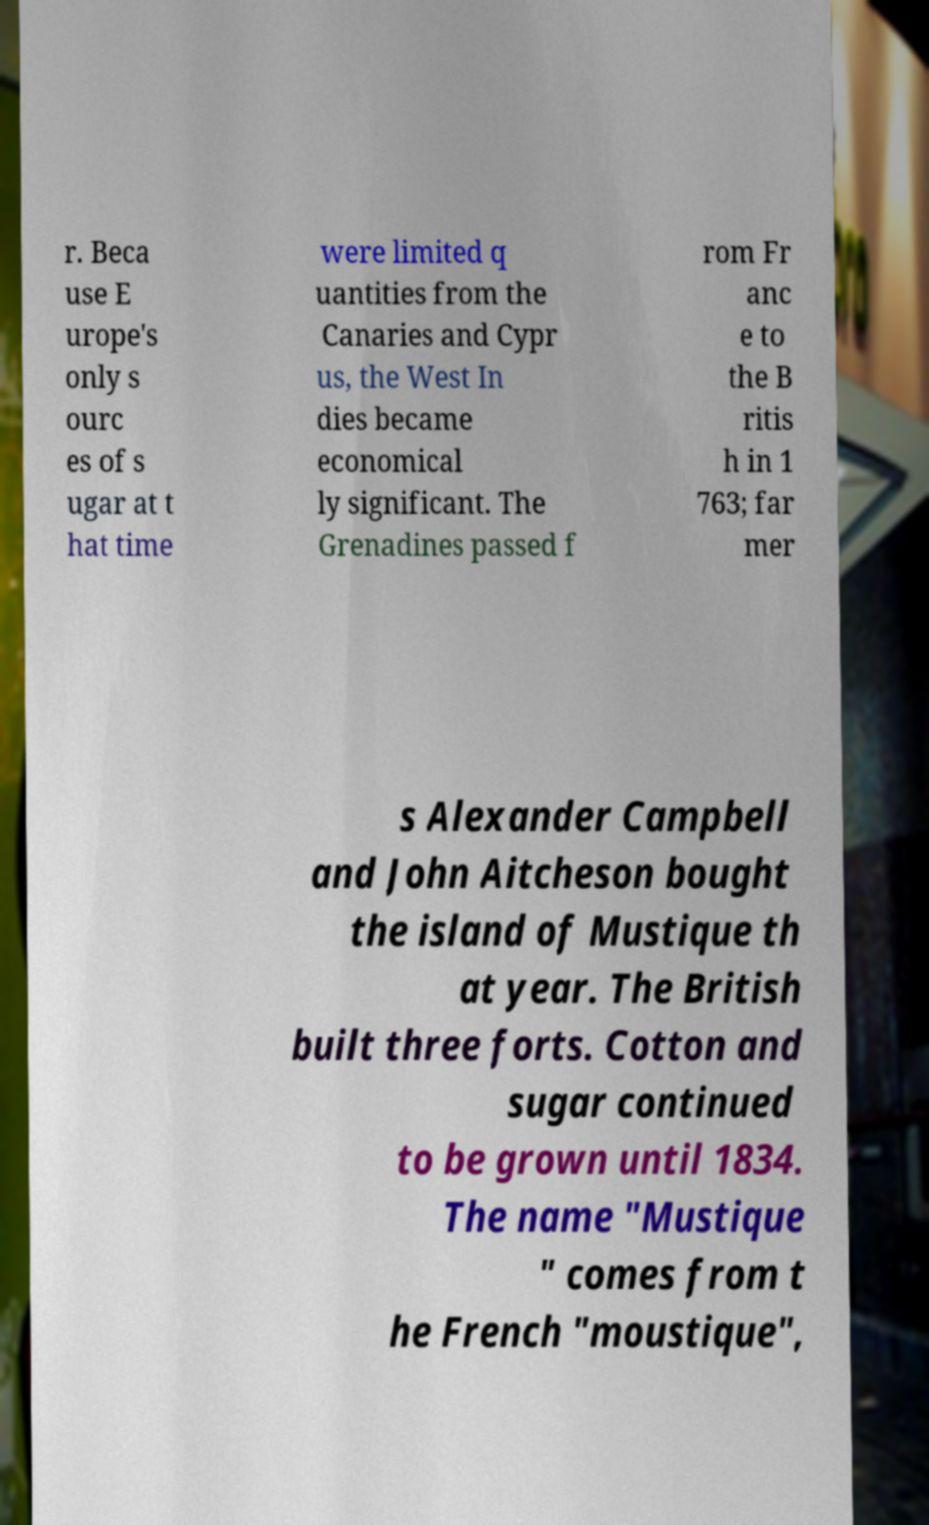For documentation purposes, I need the text within this image transcribed. Could you provide that? r. Beca use E urope's only s ourc es of s ugar at t hat time were limited q uantities from the Canaries and Cypr us, the West In dies became economical ly significant. The Grenadines passed f rom Fr anc e to the B ritis h in 1 763; far mer s Alexander Campbell and John Aitcheson bought the island of Mustique th at year. The British built three forts. Cotton and sugar continued to be grown until 1834. The name "Mustique " comes from t he French "moustique", 